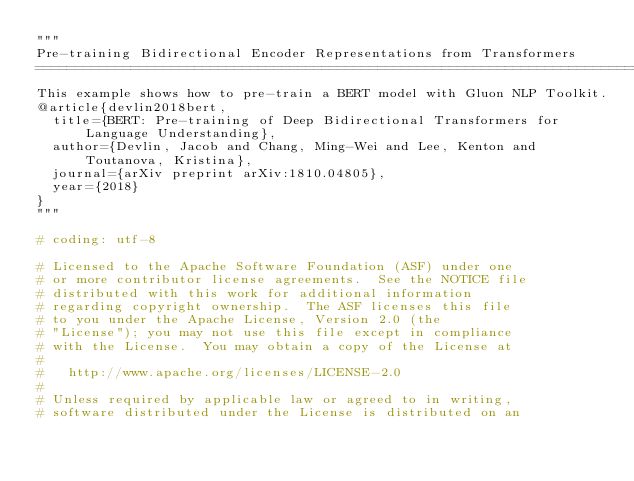Convert code to text. <code><loc_0><loc_0><loc_500><loc_500><_Python_>"""
Pre-training Bidirectional Encoder Representations from Transformers
=========================================================================================
This example shows how to pre-train a BERT model with Gluon NLP Toolkit.
@article{devlin2018bert,
  title={BERT: Pre-training of Deep Bidirectional Transformers for Language Understanding},
  author={Devlin, Jacob and Chang, Ming-Wei and Lee, Kenton and Toutanova, Kristina},
  journal={arXiv preprint arXiv:1810.04805},
  year={2018}
}
"""

# coding: utf-8

# Licensed to the Apache Software Foundation (ASF) under one
# or more contributor license agreements.  See the NOTICE file
# distributed with this work for additional information
# regarding copyright ownership.  The ASF licenses this file
# to you under the Apache License, Version 2.0 (the
# "License"); you may not use this file except in compliance
# with the License.  You may obtain a copy of the License at
#
#   http://www.apache.org/licenses/LICENSE-2.0
#
# Unless required by applicable law or agreed to in writing,
# software distributed under the License is distributed on an</code> 